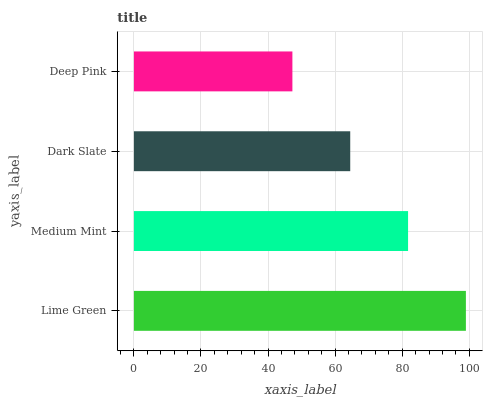Is Deep Pink the minimum?
Answer yes or no. Yes. Is Lime Green the maximum?
Answer yes or no. Yes. Is Medium Mint the minimum?
Answer yes or no. No. Is Medium Mint the maximum?
Answer yes or no. No. Is Lime Green greater than Medium Mint?
Answer yes or no. Yes. Is Medium Mint less than Lime Green?
Answer yes or no. Yes. Is Medium Mint greater than Lime Green?
Answer yes or no. No. Is Lime Green less than Medium Mint?
Answer yes or no. No. Is Medium Mint the high median?
Answer yes or no. Yes. Is Dark Slate the low median?
Answer yes or no. Yes. Is Lime Green the high median?
Answer yes or no. No. Is Lime Green the low median?
Answer yes or no. No. 